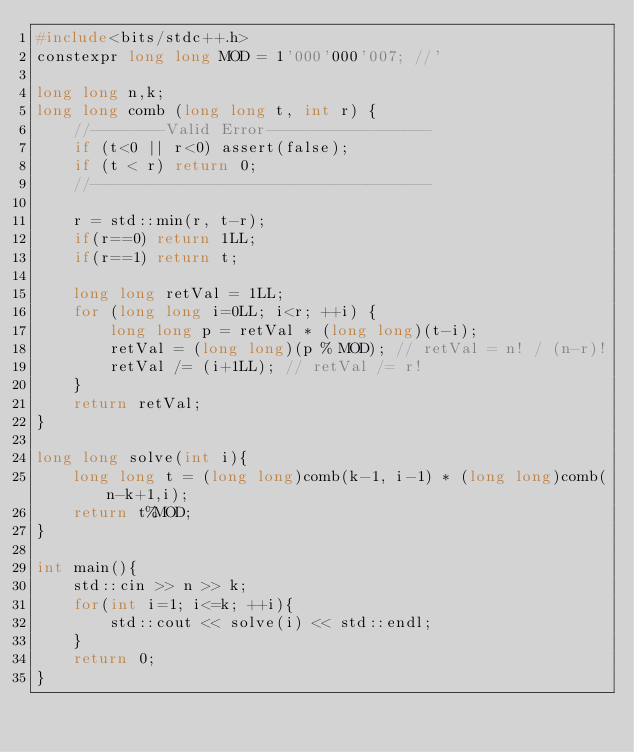Convert code to text. <code><loc_0><loc_0><loc_500><loc_500><_C_>#include<bits/stdc++.h>
constexpr long long MOD = 1'000'000'007; //'

long long n,k;
long long comb (long long t, int r) {
    //--------Valid Error------------------
    if (t<0 || r<0) assert(false);
    if (t < r) return 0;
    //-------------------------------------

    r = std::min(r, t-r);
    if(r==0) return 1LL;
    if(r==1) return t;

    long long retVal = 1LL;
    for (long long i=0LL; i<r; ++i) {
        long long p = retVal * (long long)(t-i);
        retVal = (long long)(p % MOD); // retVal = n! / (n-r)!
        retVal /= (i+1LL); // retVal /= r!
    }
    return retVal;
}

long long solve(int i){
    long long t = (long long)comb(k-1, i-1) * (long long)comb(n-k+1,i);
    return t%MOD;
}

int main(){
    std::cin >> n >> k;
    for(int i=1; i<=k; ++i){
        std::cout << solve(i) << std::endl;
    }
    return 0;
}</code> 